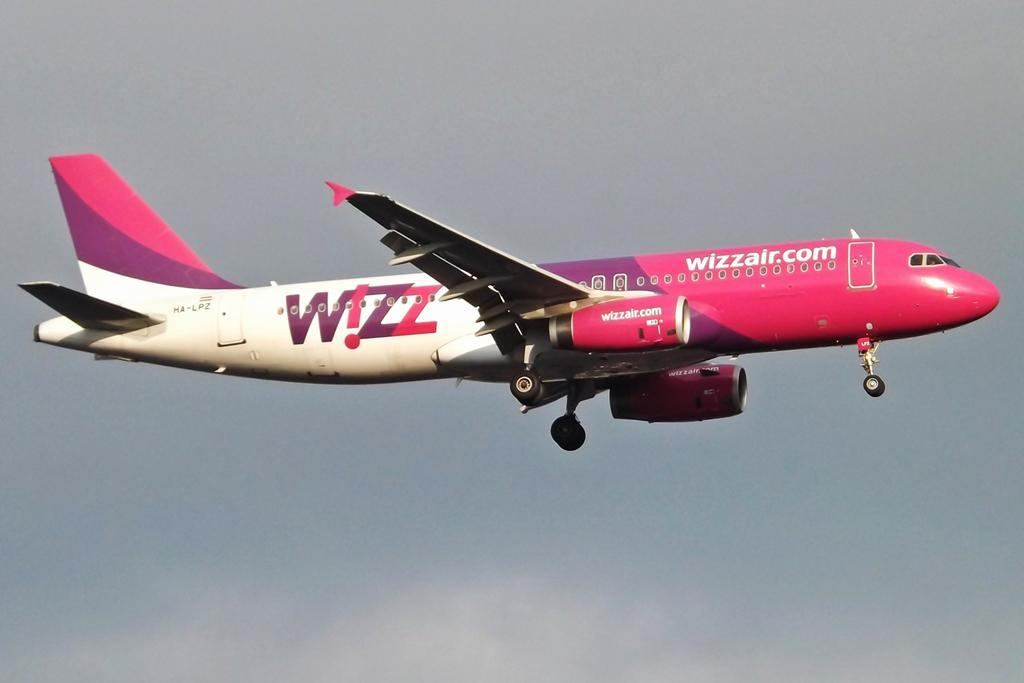<image>
Describe the image concisely. a plane that has the word Wizz on it 